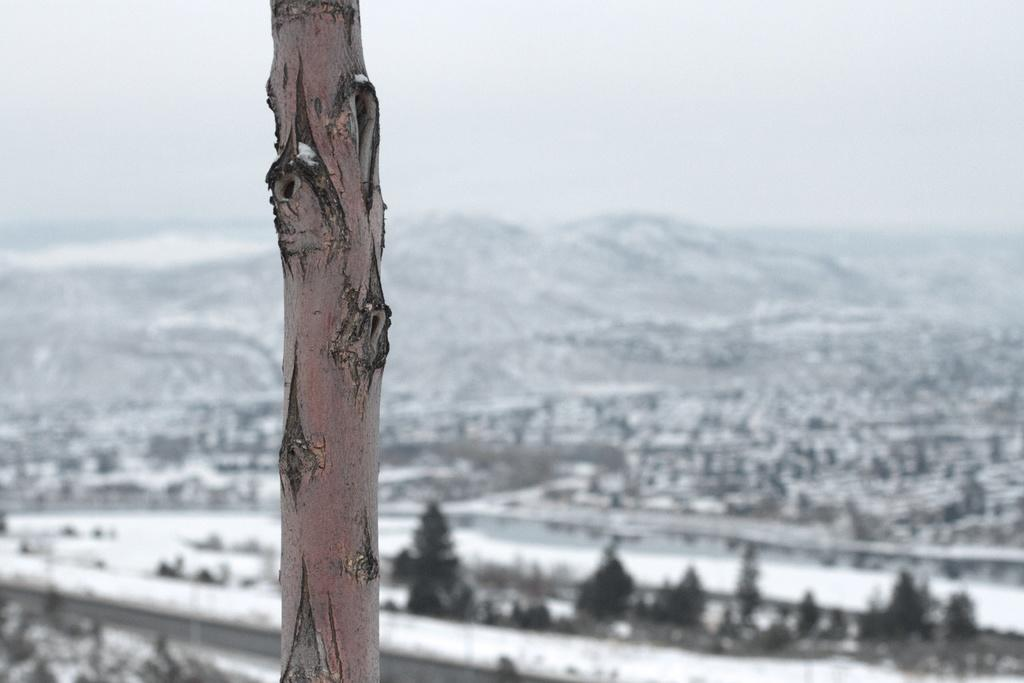What is the main subject in the foreground of the image? There is a tree trunk in the image. What can be seen in the background of the image? There are trees and mountains in the background of the image. What is visible in the sky in the image? The sky is visible in the background of the image. What color is the eye of the tank in the image? There is no tank or eye present in the image. What type of house can be seen in the background of the image? There is no house present in the image; it features a tree trunk, trees, mountains, and the sky. 